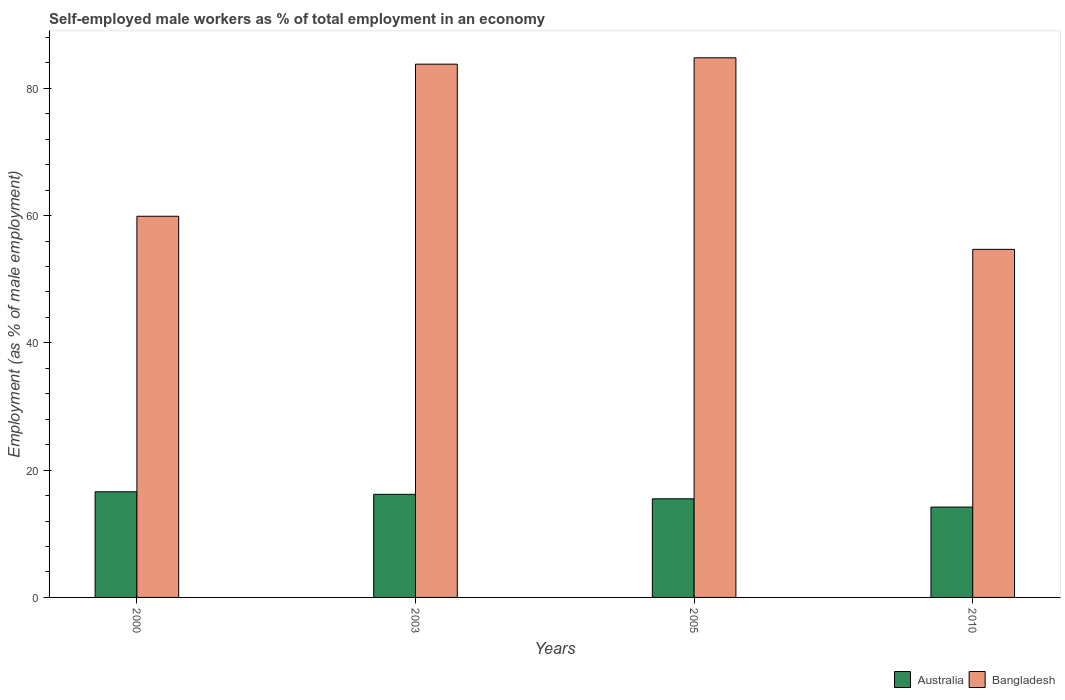How many bars are there on the 4th tick from the left?
Your response must be concise. 2. What is the percentage of self-employed male workers in Bangladesh in 2005?
Give a very brief answer. 84.8. Across all years, what is the maximum percentage of self-employed male workers in Australia?
Offer a very short reply. 16.6. Across all years, what is the minimum percentage of self-employed male workers in Bangladesh?
Your answer should be compact. 54.7. What is the total percentage of self-employed male workers in Bangladesh in the graph?
Ensure brevity in your answer.  283.2. What is the difference between the percentage of self-employed male workers in Bangladesh in 2005 and that in 2010?
Offer a terse response. 30.1. What is the difference between the percentage of self-employed male workers in Bangladesh in 2010 and the percentage of self-employed male workers in Australia in 2005?
Offer a terse response. 39.2. What is the average percentage of self-employed male workers in Bangladesh per year?
Offer a terse response. 70.8. In the year 2010, what is the difference between the percentage of self-employed male workers in Bangladesh and percentage of self-employed male workers in Australia?
Provide a succinct answer. 40.5. What is the ratio of the percentage of self-employed male workers in Bangladesh in 2000 to that in 2003?
Keep it short and to the point. 0.71. Is the percentage of self-employed male workers in Australia in 2005 less than that in 2010?
Make the answer very short. No. Is the difference between the percentage of self-employed male workers in Bangladesh in 2003 and 2005 greater than the difference between the percentage of self-employed male workers in Australia in 2003 and 2005?
Ensure brevity in your answer.  No. What is the difference between the highest and the second highest percentage of self-employed male workers in Australia?
Provide a succinct answer. 0.4. What is the difference between the highest and the lowest percentage of self-employed male workers in Bangladesh?
Your answer should be compact. 30.1. Is the sum of the percentage of self-employed male workers in Bangladesh in 2005 and 2010 greater than the maximum percentage of self-employed male workers in Australia across all years?
Make the answer very short. Yes. What does the 1st bar from the right in 2003 represents?
Provide a succinct answer. Bangladesh. How many years are there in the graph?
Offer a terse response. 4. What is the difference between two consecutive major ticks on the Y-axis?
Provide a succinct answer. 20. Are the values on the major ticks of Y-axis written in scientific E-notation?
Your response must be concise. No. Does the graph contain any zero values?
Offer a very short reply. No. What is the title of the graph?
Your answer should be very brief. Self-employed male workers as % of total employment in an economy. What is the label or title of the X-axis?
Provide a succinct answer. Years. What is the label or title of the Y-axis?
Provide a succinct answer. Employment (as % of male employment). What is the Employment (as % of male employment) of Australia in 2000?
Your answer should be compact. 16.6. What is the Employment (as % of male employment) in Bangladesh in 2000?
Offer a very short reply. 59.9. What is the Employment (as % of male employment) in Australia in 2003?
Provide a succinct answer. 16.2. What is the Employment (as % of male employment) in Bangladesh in 2003?
Your response must be concise. 83.8. What is the Employment (as % of male employment) in Bangladesh in 2005?
Offer a terse response. 84.8. What is the Employment (as % of male employment) in Australia in 2010?
Give a very brief answer. 14.2. What is the Employment (as % of male employment) in Bangladesh in 2010?
Give a very brief answer. 54.7. Across all years, what is the maximum Employment (as % of male employment) in Australia?
Provide a short and direct response. 16.6. Across all years, what is the maximum Employment (as % of male employment) in Bangladesh?
Your answer should be compact. 84.8. Across all years, what is the minimum Employment (as % of male employment) in Australia?
Offer a very short reply. 14.2. Across all years, what is the minimum Employment (as % of male employment) of Bangladesh?
Your answer should be very brief. 54.7. What is the total Employment (as % of male employment) in Australia in the graph?
Your answer should be very brief. 62.5. What is the total Employment (as % of male employment) in Bangladesh in the graph?
Your answer should be compact. 283.2. What is the difference between the Employment (as % of male employment) in Australia in 2000 and that in 2003?
Provide a short and direct response. 0.4. What is the difference between the Employment (as % of male employment) of Bangladesh in 2000 and that in 2003?
Offer a very short reply. -23.9. What is the difference between the Employment (as % of male employment) in Bangladesh in 2000 and that in 2005?
Your answer should be very brief. -24.9. What is the difference between the Employment (as % of male employment) in Australia in 2000 and that in 2010?
Offer a terse response. 2.4. What is the difference between the Employment (as % of male employment) in Bangladesh in 2000 and that in 2010?
Give a very brief answer. 5.2. What is the difference between the Employment (as % of male employment) of Bangladesh in 2003 and that in 2005?
Offer a terse response. -1. What is the difference between the Employment (as % of male employment) in Australia in 2003 and that in 2010?
Offer a terse response. 2. What is the difference between the Employment (as % of male employment) of Bangladesh in 2003 and that in 2010?
Give a very brief answer. 29.1. What is the difference between the Employment (as % of male employment) of Bangladesh in 2005 and that in 2010?
Offer a very short reply. 30.1. What is the difference between the Employment (as % of male employment) of Australia in 2000 and the Employment (as % of male employment) of Bangladesh in 2003?
Keep it short and to the point. -67.2. What is the difference between the Employment (as % of male employment) in Australia in 2000 and the Employment (as % of male employment) in Bangladesh in 2005?
Ensure brevity in your answer.  -68.2. What is the difference between the Employment (as % of male employment) of Australia in 2000 and the Employment (as % of male employment) of Bangladesh in 2010?
Your response must be concise. -38.1. What is the difference between the Employment (as % of male employment) of Australia in 2003 and the Employment (as % of male employment) of Bangladesh in 2005?
Give a very brief answer. -68.6. What is the difference between the Employment (as % of male employment) in Australia in 2003 and the Employment (as % of male employment) in Bangladesh in 2010?
Offer a terse response. -38.5. What is the difference between the Employment (as % of male employment) of Australia in 2005 and the Employment (as % of male employment) of Bangladesh in 2010?
Make the answer very short. -39.2. What is the average Employment (as % of male employment) in Australia per year?
Make the answer very short. 15.62. What is the average Employment (as % of male employment) in Bangladesh per year?
Provide a short and direct response. 70.8. In the year 2000, what is the difference between the Employment (as % of male employment) in Australia and Employment (as % of male employment) in Bangladesh?
Make the answer very short. -43.3. In the year 2003, what is the difference between the Employment (as % of male employment) of Australia and Employment (as % of male employment) of Bangladesh?
Offer a terse response. -67.6. In the year 2005, what is the difference between the Employment (as % of male employment) in Australia and Employment (as % of male employment) in Bangladesh?
Your answer should be very brief. -69.3. In the year 2010, what is the difference between the Employment (as % of male employment) in Australia and Employment (as % of male employment) in Bangladesh?
Keep it short and to the point. -40.5. What is the ratio of the Employment (as % of male employment) of Australia in 2000 to that in 2003?
Ensure brevity in your answer.  1.02. What is the ratio of the Employment (as % of male employment) of Bangladesh in 2000 to that in 2003?
Offer a very short reply. 0.71. What is the ratio of the Employment (as % of male employment) in Australia in 2000 to that in 2005?
Provide a short and direct response. 1.07. What is the ratio of the Employment (as % of male employment) in Bangladesh in 2000 to that in 2005?
Provide a short and direct response. 0.71. What is the ratio of the Employment (as % of male employment) in Australia in 2000 to that in 2010?
Give a very brief answer. 1.17. What is the ratio of the Employment (as % of male employment) in Bangladesh in 2000 to that in 2010?
Offer a very short reply. 1.1. What is the ratio of the Employment (as % of male employment) of Australia in 2003 to that in 2005?
Make the answer very short. 1.05. What is the ratio of the Employment (as % of male employment) in Australia in 2003 to that in 2010?
Provide a succinct answer. 1.14. What is the ratio of the Employment (as % of male employment) of Bangladesh in 2003 to that in 2010?
Your response must be concise. 1.53. What is the ratio of the Employment (as % of male employment) in Australia in 2005 to that in 2010?
Keep it short and to the point. 1.09. What is the ratio of the Employment (as % of male employment) in Bangladesh in 2005 to that in 2010?
Your response must be concise. 1.55. What is the difference between the highest and the second highest Employment (as % of male employment) of Bangladesh?
Ensure brevity in your answer.  1. What is the difference between the highest and the lowest Employment (as % of male employment) in Bangladesh?
Provide a succinct answer. 30.1. 